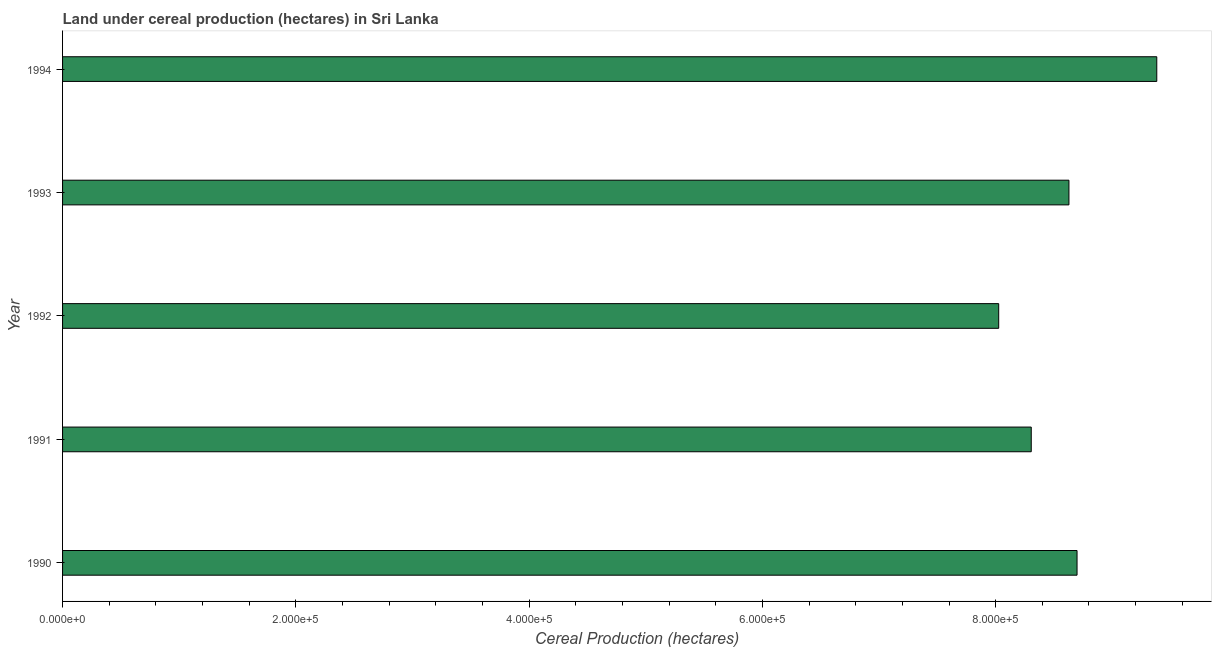Does the graph contain any zero values?
Make the answer very short. No. Does the graph contain grids?
Provide a succinct answer. No. What is the title of the graph?
Your answer should be very brief. Land under cereal production (hectares) in Sri Lanka. What is the label or title of the X-axis?
Keep it short and to the point. Cereal Production (hectares). What is the land under cereal production in 1992?
Provide a short and direct response. 8.03e+05. Across all years, what is the maximum land under cereal production?
Offer a very short reply. 9.38e+05. Across all years, what is the minimum land under cereal production?
Your answer should be compact. 8.03e+05. In which year was the land under cereal production minimum?
Offer a very short reply. 1992. What is the sum of the land under cereal production?
Provide a succinct answer. 4.30e+06. What is the difference between the land under cereal production in 1990 and 1993?
Keep it short and to the point. 6950. What is the average land under cereal production per year?
Your answer should be compact. 8.61e+05. What is the median land under cereal production?
Your answer should be compact. 8.63e+05. In how many years, is the land under cereal production greater than 160000 hectares?
Offer a very short reply. 5. What is the ratio of the land under cereal production in 1992 to that in 1994?
Your response must be concise. 0.86. Is the land under cereal production in 1990 less than that in 1991?
Offer a very short reply. No. What is the difference between the highest and the second highest land under cereal production?
Make the answer very short. 6.84e+04. What is the difference between the highest and the lowest land under cereal production?
Provide a short and direct response. 1.36e+05. In how many years, is the land under cereal production greater than the average land under cereal production taken over all years?
Provide a short and direct response. 3. Are all the bars in the graph horizontal?
Keep it short and to the point. Yes. How many years are there in the graph?
Your answer should be compact. 5. Are the values on the major ticks of X-axis written in scientific E-notation?
Offer a very short reply. Yes. What is the Cereal Production (hectares) in 1990?
Provide a succinct answer. 8.70e+05. What is the Cereal Production (hectares) in 1991?
Keep it short and to the point. 8.31e+05. What is the Cereal Production (hectares) in 1992?
Offer a very short reply. 8.03e+05. What is the Cereal Production (hectares) of 1993?
Your response must be concise. 8.63e+05. What is the Cereal Production (hectares) in 1994?
Provide a succinct answer. 9.38e+05. What is the difference between the Cereal Production (hectares) in 1990 and 1991?
Offer a terse response. 3.93e+04. What is the difference between the Cereal Production (hectares) in 1990 and 1992?
Give a very brief answer. 6.72e+04. What is the difference between the Cereal Production (hectares) in 1990 and 1993?
Your answer should be compact. 6950. What is the difference between the Cereal Production (hectares) in 1990 and 1994?
Keep it short and to the point. -6.84e+04. What is the difference between the Cereal Production (hectares) in 1991 and 1992?
Your answer should be very brief. 2.79e+04. What is the difference between the Cereal Production (hectares) in 1991 and 1993?
Your answer should be compact. -3.23e+04. What is the difference between the Cereal Production (hectares) in 1991 and 1994?
Offer a very short reply. -1.08e+05. What is the difference between the Cereal Production (hectares) in 1992 and 1993?
Give a very brief answer. -6.02e+04. What is the difference between the Cereal Production (hectares) in 1992 and 1994?
Offer a very short reply. -1.36e+05. What is the difference between the Cereal Production (hectares) in 1993 and 1994?
Ensure brevity in your answer.  -7.53e+04. What is the ratio of the Cereal Production (hectares) in 1990 to that in 1991?
Your response must be concise. 1.05. What is the ratio of the Cereal Production (hectares) in 1990 to that in 1992?
Provide a succinct answer. 1.08. What is the ratio of the Cereal Production (hectares) in 1990 to that in 1994?
Provide a short and direct response. 0.93. What is the ratio of the Cereal Production (hectares) in 1991 to that in 1992?
Ensure brevity in your answer.  1.03. What is the ratio of the Cereal Production (hectares) in 1991 to that in 1993?
Your response must be concise. 0.96. What is the ratio of the Cereal Production (hectares) in 1991 to that in 1994?
Provide a short and direct response. 0.89. What is the ratio of the Cereal Production (hectares) in 1992 to that in 1993?
Offer a very short reply. 0.93. What is the ratio of the Cereal Production (hectares) in 1992 to that in 1994?
Your answer should be very brief. 0.86. 